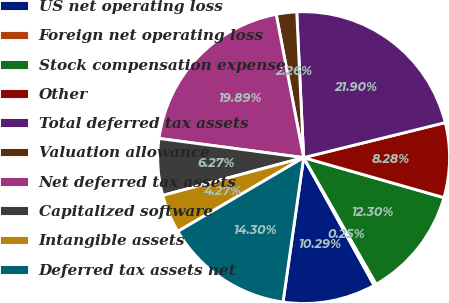Convert chart. <chart><loc_0><loc_0><loc_500><loc_500><pie_chart><fcel>US net operating loss<fcel>Foreign net operating loss<fcel>Stock compensation expense<fcel>Other<fcel>Total deferred tax assets<fcel>Valuation allowance<fcel>Net deferred tax assets<fcel>Capitalized software<fcel>Intangible assets<fcel>Deferred tax assets net<nl><fcel>10.29%<fcel>0.25%<fcel>12.3%<fcel>8.28%<fcel>21.9%<fcel>2.26%<fcel>19.89%<fcel>6.27%<fcel>4.27%<fcel>14.3%<nl></chart> 